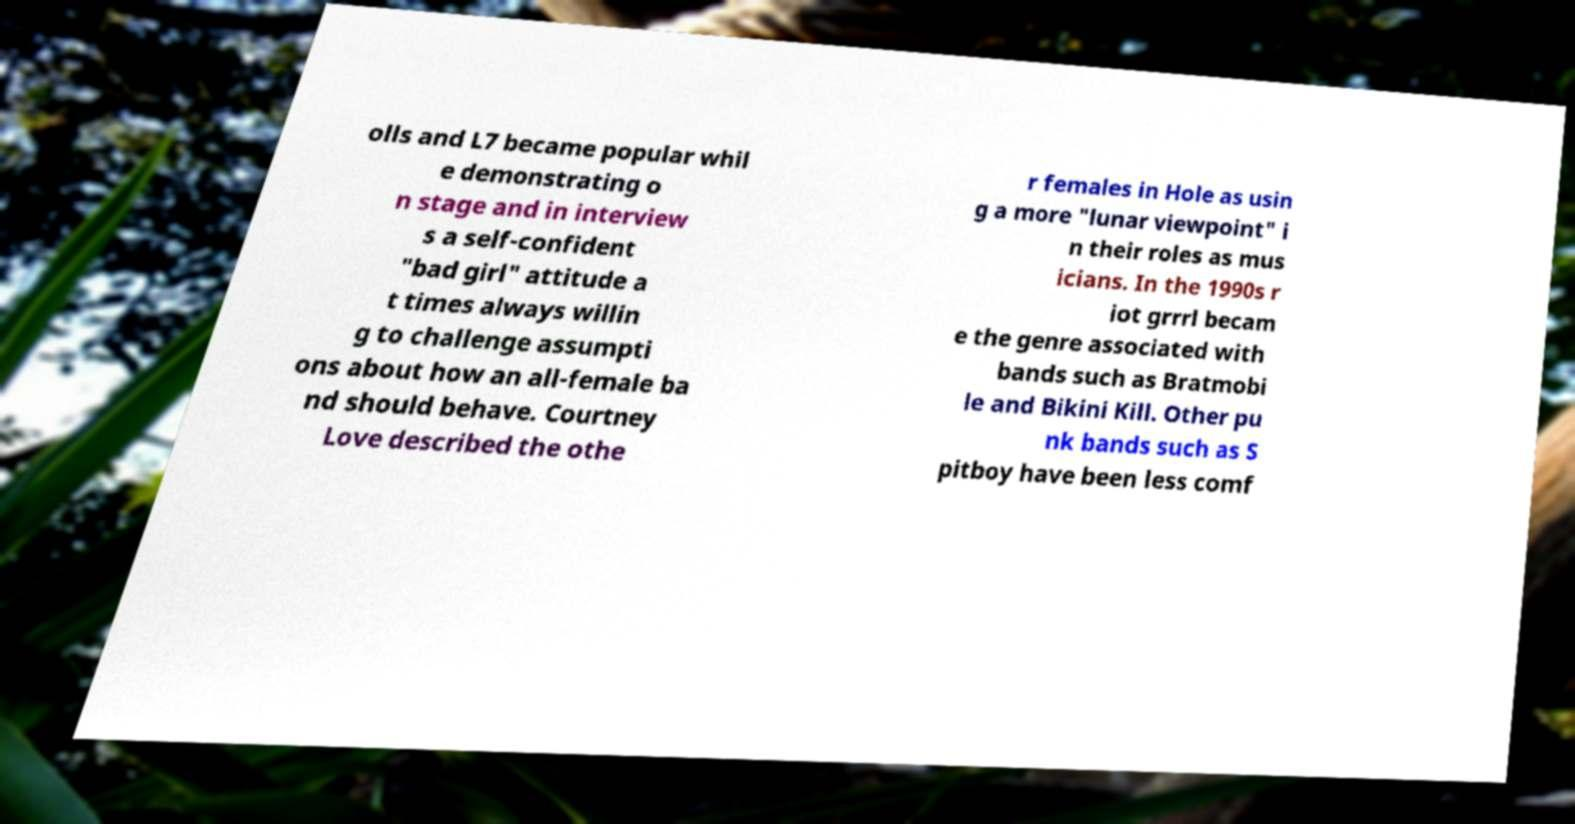I need the written content from this picture converted into text. Can you do that? olls and L7 became popular whil e demonstrating o n stage and in interview s a self-confident "bad girl" attitude a t times always willin g to challenge assumpti ons about how an all-female ba nd should behave. Courtney Love described the othe r females in Hole as usin g a more "lunar viewpoint" i n their roles as mus icians. In the 1990s r iot grrrl becam e the genre associated with bands such as Bratmobi le and Bikini Kill. Other pu nk bands such as S pitboy have been less comf 